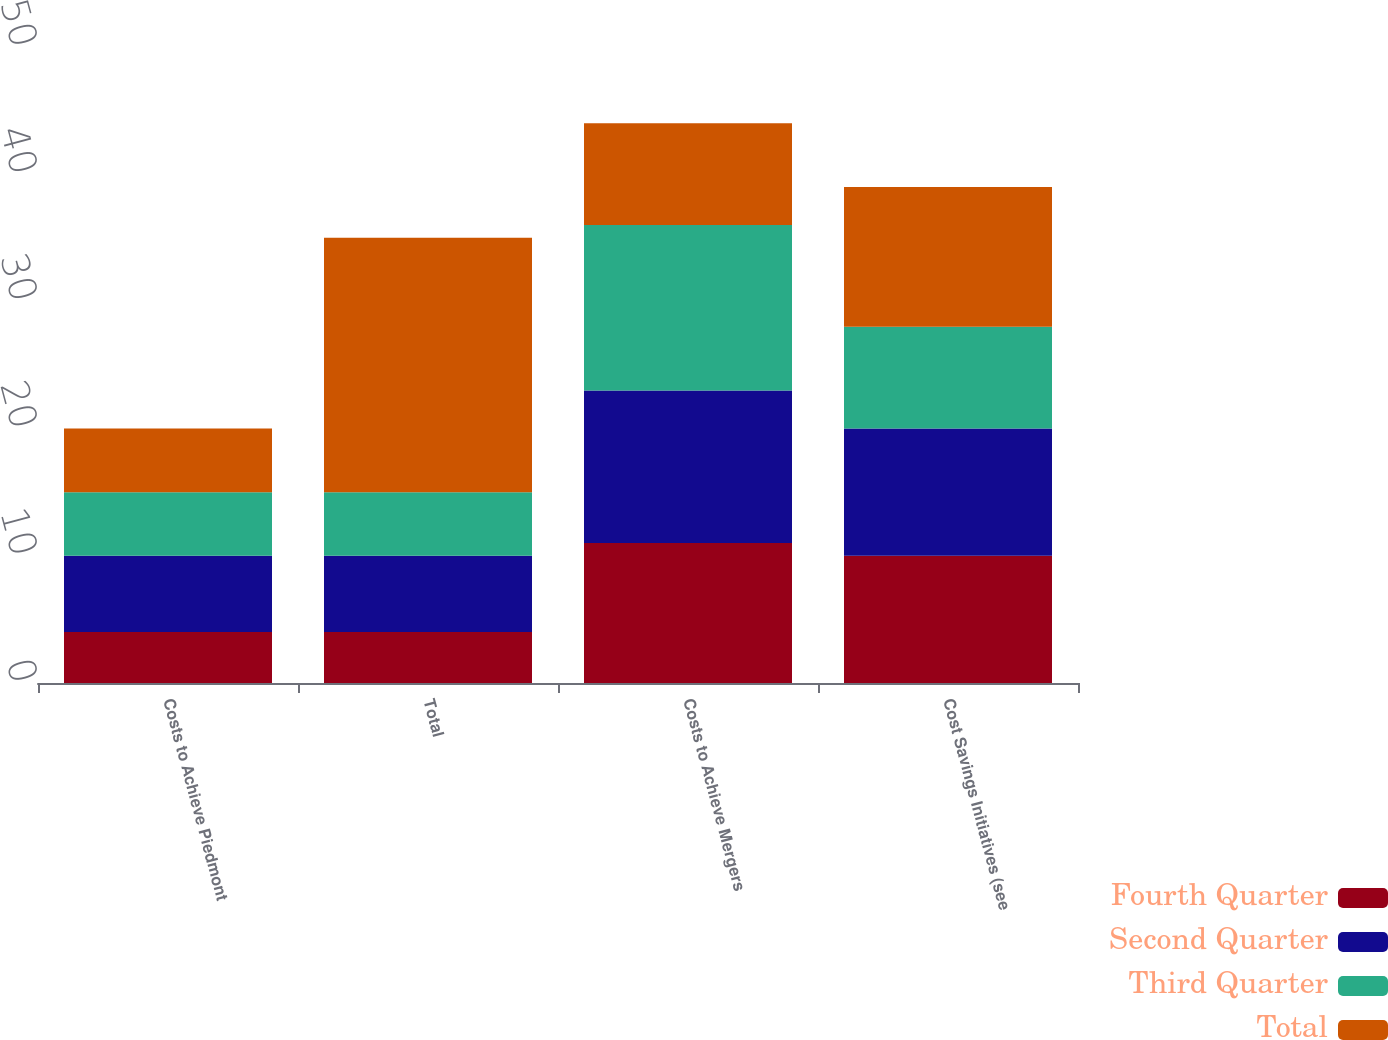Convert chart to OTSL. <chart><loc_0><loc_0><loc_500><loc_500><stacked_bar_chart><ecel><fcel>Costs to Achieve Piedmont<fcel>Total<fcel>Costs to Achieve Mergers<fcel>Cost Savings Initiatives (see<nl><fcel>Fourth Quarter<fcel>4<fcel>4<fcel>11<fcel>10<nl><fcel>Second Quarter<fcel>6<fcel>6<fcel>12<fcel>10<nl><fcel>Third Quarter<fcel>5<fcel>5<fcel>13<fcel>8<nl><fcel>Total<fcel>5<fcel>20<fcel>8<fcel>11<nl></chart> 